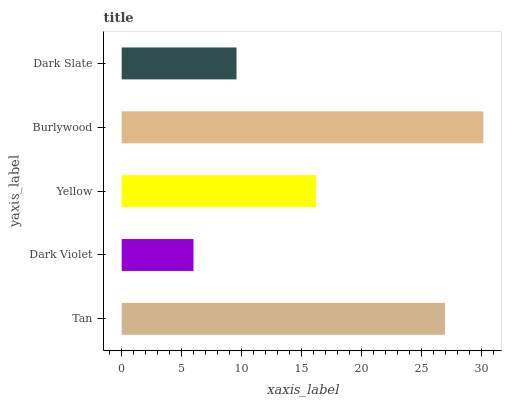Is Dark Violet the minimum?
Answer yes or no. Yes. Is Burlywood the maximum?
Answer yes or no. Yes. Is Yellow the minimum?
Answer yes or no. No. Is Yellow the maximum?
Answer yes or no. No. Is Yellow greater than Dark Violet?
Answer yes or no. Yes. Is Dark Violet less than Yellow?
Answer yes or no. Yes. Is Dark Violet greater than Yellow?
Answer yes or no. No. Is Yellow less than Dark Violet?
Answer yes or no. No. Is Yellow the high median?
Answer yes or no. Yes. Is Yellow the low median?
Answer yes or no. Yes. Is Tan the high median?
Answer yes or no. No. Is Dark Slate the low median?
Answer yes or no. No. 